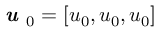<formula> <loc_0><loc_0><loc_500><loc_500>\em u _ { 0 } = [ u _ { 0 } , u _ { 0 } , u _ { 0 } ]</formula> 